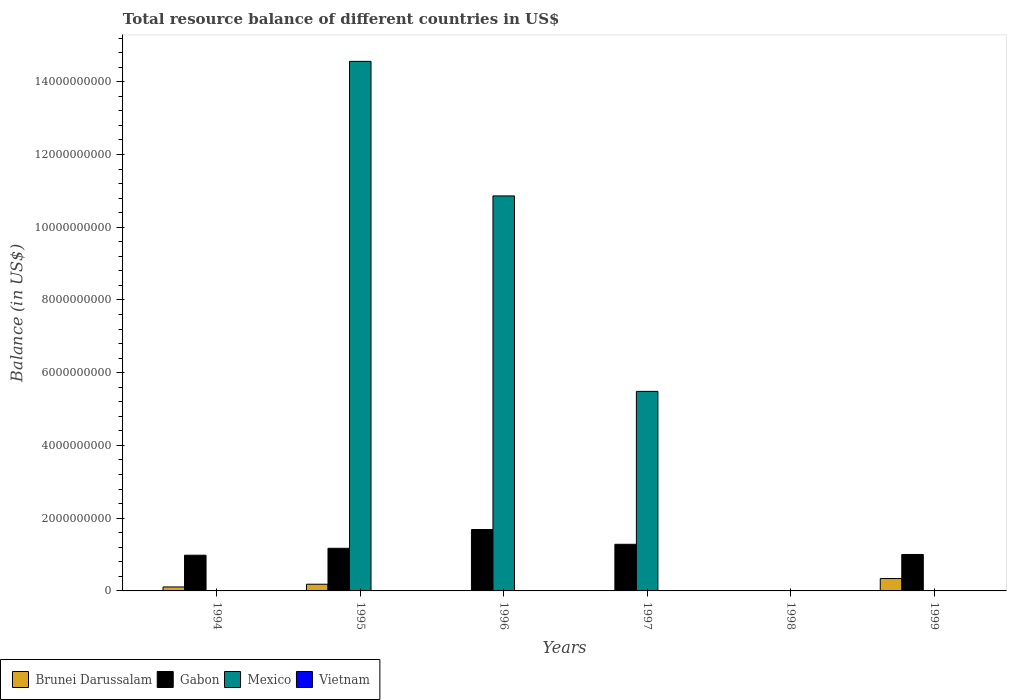How many different coloured bars are there?
Provide a succinct answer. 3. How many bars are there on the 3rd tick from the left?
Make the answer very short. 2. How many bars are there on the 2nd tick from the right?
Provide a succinct answer. 0. What is the label of the 2nd group of bars from the left?
Keep it short and to the point. 1995. Across all years, what is the maximum total resource balance in Brunei Darussalam?
Your answer should be compact. 3.41e+08. Across all years, what is the minimum total resource balance in Vietnam?
Offer a very short reply. 0. In which year was the total resource balance in Gabon maximum?
Your answer should be compact. 1996. What is the total total resource balance in Mexico in the graph?
Ensure brevity in your answer.  3.09e+1. What is the difference between the total resource balance in Gabon in 1994 and that in 1999?
Keep it short and to the point. -2.06e+07. What is the average total resource balance in Brunei Darussalam per year?
Offer a terse response. 1.06e+08. In the year 1997, what is the difference between the total resource balance in Gabon and total resource balance in Mexico?
Offer a very short reply. -4.20e+09. What is the ratio of the total resource balance in Gabon in 1996 to that in 1997?
Provide a succinct answer. 1.32. Is the total resource balance in Brunei Darussalam in 1994 less than that in 1995?
Keep it short and to the point. Yes. Is the difference between the total resource balance in Gabon in 1996 and 1997 greater than the difference between the total resource balance in Mexico in 1996 and 1997?
Your answer should be compact. No. What is the difference between the highest and the second highest total resource balance in Gabon?
Your answer should be compact. 4.06e+08. What is the difference between the highest and the lowest total resource balance in Gabon?
Your answer should be very brief. 1.69e+09. In how many years, is the total resource balance in Mexico greater than the average total resource balance in Mexico taken over all years?
Ensure brevity in your answer.  3. Is it the case that in every year, the sum of the total resource balance in Gabon and total resource balance in Brunei Darussalam is greater than the sum of total resource balance in Vietnam and total resource balance in Mexico?
Keep it short and to the point. No. How many years are there in the graph?
Make the answer very short. 6. How many legend labels are there?
Your answer should be very brief. 4. How are the legend labels stacked?
Ensure brevity in your answer.  Horizontal. What is the title of the graph?
Ensure brevity in your answer.  Total resource balance of different countries in US$. Does "Liberia" appear as one of the legend labels in the graph?
Offer a very short reply. No. What is the label or title of the X-axis?
Provide a succinct answer. Years. What is the label or title of the Y-axis?
Provide a succinct answer. Balance (in US$). What is the Balance (in US$) of Brunei Darussalam in 1994?
Your response must be concise. 1.09e+08. What is the Balance (in US$) of Gabon in 1994?
Give a very brief answer. 9.82e+08. What is the Balance (in US$) of Mexico in 1994?
Make the answer very short. 0. What is the Balance (in US$) of Brunei Darussalam in 1995?
Your answer should be compact. 1.84e+08. What is the Balance (in US$) in Gabon in 1995?
Ensure brevity in your answer.  1.17e+09. What is the Balance (in US$) in Mexico in 1995?
Provide a short and direct response. 1.46e+1. What is the Balance (in US$) of Gabon in 1996?
Offer a terse response. 1.69e+09. What is the Balance (in US$) of Mexico in 1996?
Ensure brevity in your answer.  1.09e+1. What is the Balance (in US$) of Vietnam in 1996?
Keep it short and to the point. 0. What is the Balance (in US$) in Gabon in 1997?
Keep it short and to the point. 1.28e+09. What is the Balance (in US$) of Mexico in 1997?
Keep it short and to the point. 5.49e+09. What is the Balance (in US$) of Vietnam in 1997?
Keep it short and to the point. 0. What is the Balance (in US$) in Brunei Darussalam in 1998?
Provide a succinct answer. 0. What is the Balance (in US$) of Mexico in 1998?
Your response must be concise. 0. What is the Balance (in US$) of Vietnam in 1998?
Give a very brief answer. 0. What is the Balance (in US$) in Brunei Darussalam in 1999?
Ensure brevity in your answer.  3.41e+08. What is the Balance (in US$) of Gabon in 1999?
Give a very brief answer. 1.00e+09. What is the Balance (in US$) in Mexico in 1999?
Give a very brief answer. 0. What is the Balance (in US$) of Vietnam in 1999?
Make the answer very short. 0. Across all years, what is the maximum Balance (in US$) of Brunei Darussalam?
Provide a short and direct response. 3.41e+08. Across all years, what is the maximum Balance (in US$) in Gabon?
Keep it short and to the point. 1.69e+09. Across all years, what is the maximum Balance (in US$) of Mexico?
Provide a succinct answer. 1.46e+1. Across all years, what is the minimum Balance (in US$) in Gabon?
Give a very brief answer. 0. What is the total Balance (in US$) of Brunei Darussalam in the graph?
Keep it short and to the point. 6.34e+08. What is the total Balance (in US$) of Gabon in the graph?
Your answer should be compact. 6.13e+09. What is the total Balance (in US$) in Mexico in the graph?
Give a very brief answer. 3.09e+1. What is the total Balance (in US$) of Vietnam in the graph?
Offer a terse response. 0. What is the difference between the Balance (in US$) in Brunei Darussalam in 1994 and that in 1995?
Offer a terse response. -7.48e+07. What is the difference between the Balance (in US$) of Gabon in 1994 and that in 1995?
Provide a short and direct response. -1.91e+08. What is the difference between the Balance (in US$) in Gabon in 1994 and that in 1996?
Make the answer very short. -7.07e+08. What is the difference between the Balance (in US$) of Gabon in 1994 and that in 1997?
Offer a terse response. -3.01e+08. What is the difference between the Balance (in US$) of Brunei Darussalam in 1994 and that in 1999?
Provide a short and direct response. -2.32e+08. What is the difference between the Balance (in US$) of Gabon in 1994 and that in 1999?
Keep it short and to the point. -2.06e+07. What is the difference between the Balance (in US$) in Gabon in 1995 and that in 1996?
Ensure brevity in your answer.  -5.16e+08. What is the difference between the Balance (in US$) of Mexico in 1995 and that in 1996?
Your response must be concise. 3.70e+09. What is the difference between the Balance (in US$) in Gabon in 1995 and that in 1997?
Provide a succinct answer. -1.10e+08. What is the difference between the Balance (in US$) of Mexico in 1995 and that in 1997?
Offer a very short reply. 9.07e+09. What is the difference between the Balance (in US$) in Brunei Darussalam in 1995 and that in 1999?
Your answer should be compact. -1.57e+08. What is the difference between the Balance (in US$) of Gabon in 1995 and that in 1999?
Your answer should be compact. 1.70e+08. What is the difference between the Balance (in US$) of Gabon in 1996 and that in 1997?
Your answer should be compact. 4.06e+08. What is the difference between the Balance (in US$) of Mexico in 1996 and that in 1997?
Make the answer very short. 5.37e+09. What is the difference between the Balance (in US$) of Gabon in 1996 and that in 1999?
Ensure brevity in your answer.  6.86e+08. What is the difference between the Balance (in US$) of Gabon in 1997 and that in 1999?
Your answer should be very brief. 2.80e+08. What is the difference between the Balance (in US$) in Brunei Darussalam in 1994 and the Balance (in US$) in Gabon in 1995?
Your answer should be very brief. -1.06e+09. What is the difference between the Balance (in US$) in Brunei Darussalam in 1994 and the Balance (in US$) in Mexico in 1995?
Give a very brief answer. -1.45e+1. What is the difference between the Balance (in US$) of Gabon in 1994 and the Balance (in US$) of Mexico in 1995?
Offer a very short reply. -1.36e+1. What is the difference between the Balance (in US$) of Brunei Darussalam in 1994 and the Balance (in US$) of Gabon in 1996?
Offer a very short reply. -1.58e+09. What is the difference between the Balance (in US$) in Brunei Darussalam in 1994 and the Balance (in US$) in Mexico in 1996?
Provide a succinct answer. -1.08e+1. What is the difference between the Balance (in US$) in Gabon in 1994 and the Balance (in US$) in Mexico in 1996?
Ensure brevity in your answer.  -9.88e+09. What is the difference between the Balance (in US$) of Brunei Darussalam in 1994 and the Balance (in US$) of Gabon in 1997?
Provide a succinct answer. -1.17e+09. What is the difference between the Balance (in US$) of Brunei Darussalam in 1994 and the Balance (in US$) of Mexico in 1997?
Provide a short and direct response. -5.38e+09. What is the difference between the Balance (in US$) of Gabon in 1994 and the Balance (in US$) of Mexico in 1997?
Ensure brevity in your answer.  -4.50e+09. What is the difference between the Balance (in US$) in Brunei Darussalam in 1994 and the Balance (in US$) in Gabon in 1999?
Offer a terse response. -8.93e+08. What is the difference between the Balance (in US$) of Brunei Darussalam in 1995 and the Balance (in US$) of Gabon in 1996?
Offer a very short reply. -1.50e+09. What is the difference between the Balance (in US$) in Brunei Darussalam in 1995 and the Balance (in US$) in Mexico in 1996?
Offer a terse response. -1.07e+1. What is the difference between the Balance (in US$) in Gabon in 1995 and the Balance (in US$) in Mexico in 1996?
Offer a terse response. -9.69e+09. What is the difference between the Balance (in US$) in Brunei Darussalam in 1995 and the Balance (in US$) in Gabon in 1997?
Keep it short and to the point. -1.10e+09. What is the difference between the Balance (in US$) of Brunei Darussalam in 1995 and the Balance (in US$) of Mexico in 1997?
Offer a terse response. -5.30e+09. What is the difference between the Balance (in US$) of Gabon in 1995 and the Balance (in US$) of Mexico in 1997?
Ensure brevity in your answer.  -4.31e+09. What is the difference between the Balance (in US$) of Brunei Darussalam in 1995 and the Balance (in US$) of Gabon in 1999?
Offer a very short reply. -8.18e+08. What is the difference between the Balance (in US$) of Gabon in 1996 and the Balance (in US$) of Mexico in 1997?
Your answer should be compact. -3.80e+09. What is the average Balance (in US$) in Brunei Darussalam per year?
Your response must be concise. 1.06e+08. What is the average Balance (in US$) in Gabon per year?
Give a very brief answer. 1.02e+09. What is the average Balance (in US$) in Mexico per year?
Provide a succinct answer. 5.15e+09. What is the average Balance (in US$) of Vietnam per year?
Offer a very short reply. 0. In the year 1994, what is the difference between the Balance (in US$) in Brunei Darussalam and Balance (in US$) in Gabon?
Give a very brief answer. -8.72e+08. In the year 1995, what is the difference between the Balance (in US$) in Brunei Darussalam and Balance (in US$) in Gabon?
Your answer should be very brief. -9.88e+08. In the year 1995, what is the difference between the Balance (in US$) of Brunei Darussalam and Balance (in US$) of Mexico?
Offer a very short reply. -1.44e+1. In the year 1995, what is the difference between the Balance (in US$) in Gabon and Balance (in US$) in Mexico?
Your answer should be very brief. -1.34e+1. In the year 1996, what is the difference between the Balance (in US$) in Gabon and Balance (in US$) in Mexico?
Keep it short and to the point. -9.17e+09. In the year 1997, what is the difference between the Balance (in US$) in Gabon and Balance (in US$) in Mexico?
Offer a terse response. -4.20e+09. In the year 1999, what is the difference between the Balance (in US$) in Brunei Darussalam and Balance (in US$) in Gabon?
Provide a short and direct response. -6.61e+08. What is the ratio of the Balance (in US$) in Brunei Darussalam in 1994 to that in 1995?
Keep it short and to the point. 0.59. What is the ratio of the Balance (in US$) of Gabon in 1994 to that in 1995?
Your answer should be very brief. 0.84. What is the ratio of the Balance (in US$) in Gabon in 1994 to that in 1996?
Make the answer very short. 0.58. What is the ratio of the Balance (in US$) of Gabon in 1994 to that in 1997?
Make the answer very short. 0.77. What is the ratio of the Balance (in US$) of Brunei Darussalam in 1994 to that in 1999?
Your answer should be very brief. 0.32. What is the ratio of the Balance (in US$) in Gabon in 1994 to that in 1999?
Ensure brevity in your answer.  0.98. What is the ratio of the Balance (in US$) of Gabon in 1995 to that in 1996?
Offer a very short reply. 0.69. What is the ratio of the Balance (in US$) in Mexico in 1995 to that in 1996?
Provide a succinct answer. 1.34. What is the ratio of the Balance (in US$) of Gabon in 1995 to that in 1997?
Your response must be concise. 0.91. What is the ratio of the Balance (in US$) of Mexico in 1995 to that in 1997?
Provide a short and direct response. 2.65. What is the ratio of the Balance (in US$) in Brunei Darussalam in 1995 to that in 1999?
Your answer should be very brief. 0.54. What is the ratio of the Balance (in US$) of Gabon in 1995 to that in 1999?
Keep it short and to the point. 1.17. What is the ratio of the Balance (in US$) in Gabon in 1996 to that in 1997?
Your answer should be compact. 1.32. What is the ratio of the Balance (in US$) of Mexico in 1996 to that in 1997?
Your answer should be compact. 1.98. What is the ratio of the Balance (in US$) in Gabon in 1996 to that in 1999?
Your answer should be compact. 1.68. What is the ratio of the Balance (in US$) in Gabon in 1997 to that in 1999?
Your answer should be very brief. 1.28. What is the difference between the highest and the second highest Balance (in US$) of Brunei Darussalam?
Offer a very short reply. 1.57e+08. What is the difference between the highest and the second highest Balance (in US$) of Gabon?
Your answer should be compact. 4.06e+08. What is the difference between the highest and the second highest Balance (in US$) of Mexico?
Provide a succinct answer. 3.70e+09. What is the difference between the highest and the lowest Balance (in US$) of Brunei Darussalam?
Offer a very short reply. 3.41e+08. What is the difference between the highest and the lowest Balance (in US$) in Gabon?
Make the answer very short. 1.69e+09. What is the difference between the highest and the lowest Balance (in US$) in Mexico?
Keep it short and to the point. 1.46e+1. 